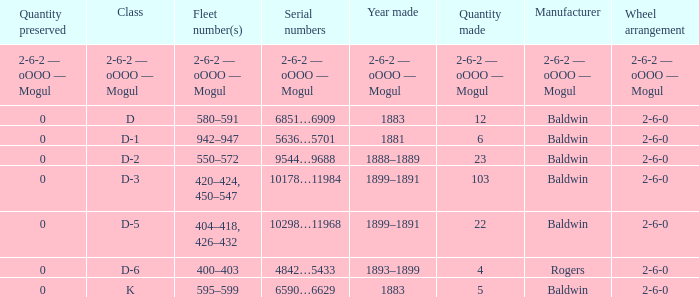What is the wheel arrangement when the year made is 1881? 2-6-0. 